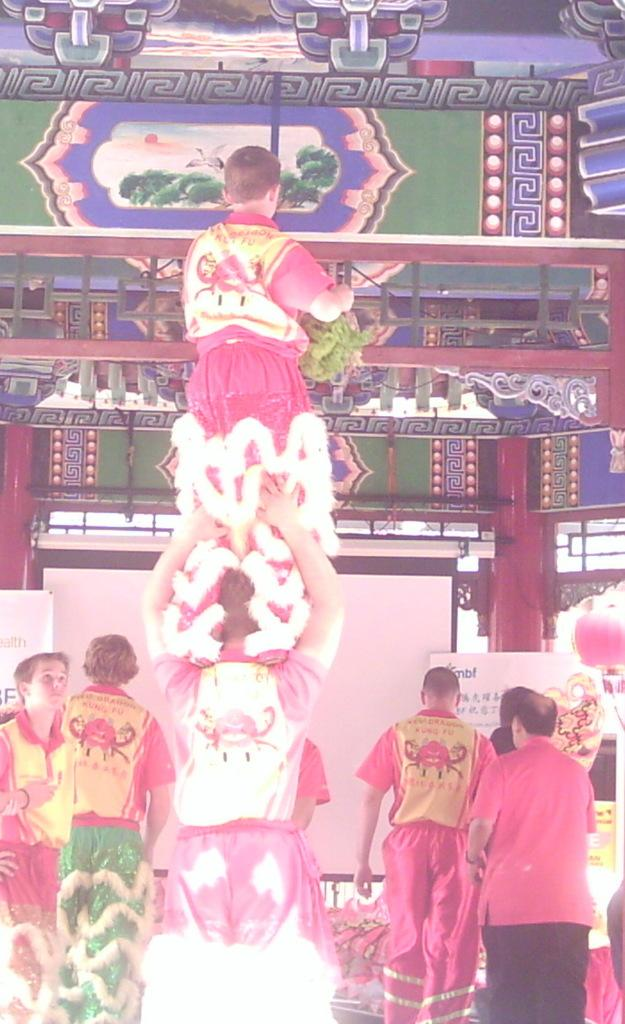What can be seen in the image? There are people standing in the image. Where are the people located in the image? The people are at the bottom of the image. What else is present in the image besides the people? There is a wall poster in the image. Where is the wall poster located in the image? The wall poster is at the top of the image. What type of advice can be seen on the nest in the image? There is no nest present in the image, and therefore no advice can be seen on it. 